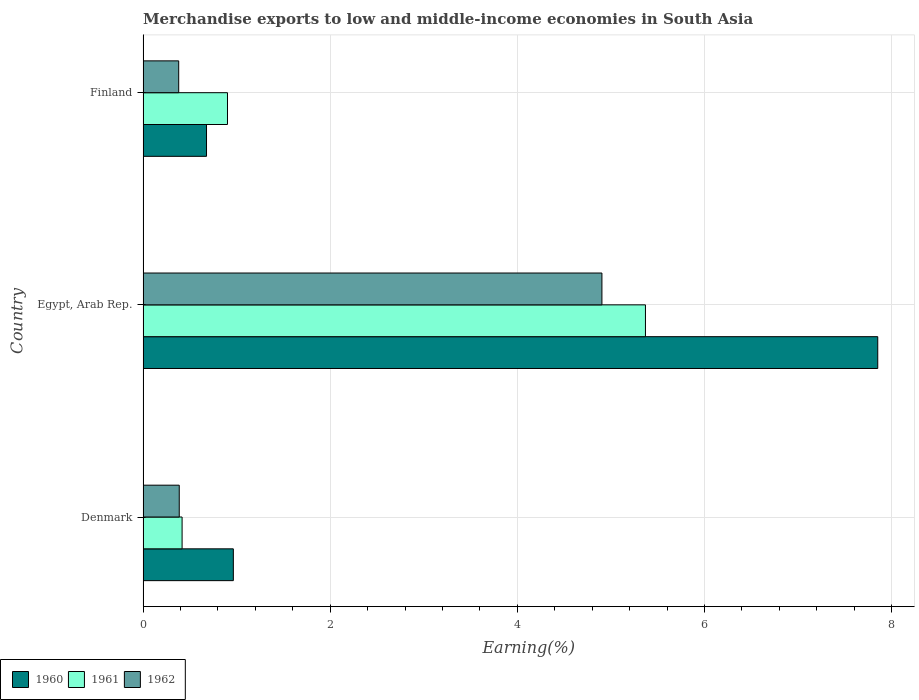How many different coloured bars are there?
Your answer should be very brief. 3. How many groups of bars are there?
Keep it short and to the point. 3. Are the number of bars per tick equal to the number of legend labels?
Offer a terse response. Yes. Are the number of bars on each tick of the Y-axis equal?
Offer a very short reply. Yes. How many bars are there on the 3rd tick from the bottom?
Keep it short and to the point. 3. What is the percentage of amount earned from merchandise exports in 1960 in Denmark?
Your answer should be compact. 0.96. Across all countries, what is the maximum percentage of amount earned from merchandise exports in 1961?
Make the answer very short. 5.37. Across all countries, what is the minimum percentage of amount earned from merchandise exports in 1961?
Keep it short and to the point. 0.42. In which country was the percentage of amount earned from merchandise exports in 1962 maximum?
Provide a short and direct response. Egypt, Arab Rep. In which country was the percentage of amount earned from merchandise exports in 1962 minimum?
Your answer should be compact. Finland. What is the total percentage of amount earned from merchandise exports in 1961 in the graph?
Your answer should be very brief. 6.69. What is the difference between the percentage of amount earned from merchandise exports in 1960 in Denmark and that in Egypt, Arab Rep.?
Give a very brief answer. -6.89. What is the difference between the percentage of amount earned from merchandise exports in 1962 in Denmark and the percentage of amount earned from merchandise exports in 1960 in Egypt, Arab Rep.?
Your response must be concise. -7.46. What is the average percentage of amount earned from merchandise exports in 1960 per country?
Provide a succinct answer. 3.16. What is the difference between the percentage of amount earned from merchandise exports in 1961 and percentage of amount earned from merchandise exports in 1962 in Egypt, Arab Rep.?
Ensure brevity in your answer.  0.47. In how many countries, is the percentage of amount earned from merchandise exports in 1962 greater than 7.2 %?
Provide a short and direct response. 0. What is the ratio of the percentage of amount earned from merchandise exports in 1961 in Denmark to that in Finland?
Ensure brevity in your answer.  0.46. Is the percentage of amount earned from merchandise exports in 1960 in Denmark less than that in Finland?
Provide a short and direct response. No. Is the difference between the percentage of amount earned from merchandise exports in 1961 in Denmark and Finland greater than the difference between the percentage of amount earned from merchandise exports in 1962 in Denmark and Finland?
Provide a short and direct response. No. What is the difference between the highest and the second highest percentage of amount earned from merchandise exports in 1960?
Your answer should be very brief. 6.89. What is the difference between the highest and the lowest percentage of amount earned from merchandise exports in 1961?
Keep it short and to the point. 4.95. In how many countries, is the percentage of amount earned from merchandise exports in 1962 greater than the average percentage of amount earned from merchandise exports in 1962 taken over all countries?
Your response must be concise. 1. What does the 1st bar from the bottom in Finland represents?
Give a very brief answer. 1960. Are all the bars in the graph horizontal?
Keep it short and to the point. Yes. Are the values on the major ticks of X-axis written in scientific E-notation?
Make the answer very short. No. Does the graph contain any zero values?
Offer a terse response. No. What is the title of the graph?
Offer a terse response. Merchandise exports to low and middle-income economies in South Asia. Does "2000" appear as one of the legend labels in the graph?
Ensure brevity in your answer.  No. What is the label or title of the X-axis?
Keep it short and to the point. Earning(%). What is the Earning(%) of 1960 in Denmark?
Your answer should be very brief. 0.96. What is the Earning(%) in 1961 in Denmark?
Offer a very short reply. 0.42. What is the Earning(%) of 1962 in Denmark?
Your answer should be compact. 0.39. What is the Earning(%) of 1960 in Egypt, Arab Rep.?
Make the answer very short. 7.85. What is the Earning(%) in 1961 in Egypt, Arab Rep.?
Make the answer very short. 5.37. What is the Earning(%) in 1962 in Egypt, Arab Rep.?
Ensure brevity in your answer.  4.9. What is the Earning(%) of 1960 in Finland?
Keep it short and to the point. 0.68. What is the Earning(%) in 1961 in Finland?
Ensure brevity in your answer.  0.9. What is the Earning(%) of 1962 in Finland?
Make the answer very short. 0.38. Across all countries, what is the maximum Earning(%) of 1960?
Your answer should be compact. 7.85. Across all countries, what is the maximum Earning(%) in 1961?
Offer a terse response. 5.37. Across all countries, what is the maximum Earning(%) in 1962?
Give a very brief answer. 4.9. Across all countries, what is the minimum Earning(%) in 1960?
Your response must be concise. 0.68. Across all countries, what is the minimum Earning(%) of 1961?
Ensure brevity in your answer.  0.42. Across all countries, what is the minimum Earning(%) of 1962?
Offer a terse response. 0.38. What is the total Earning(%) in 1960 in the graph?
Provide a short and direct response. 9.49. What is the total Earning(%) in 1961 in the graph?
Offer a very short reply. 6.69. What is the total Earning(%) of 1962 in the graph?
Your response must be concise. 5.67. What is the difference between the Earning(%) of 1960 in Denmark and that in Egypt, Arab Rep.?
Keep it short and to the point. -6.89. What is the difference between the Earning(%) of 1961 in Denmark and that in Egypt, Arab Rep.?
Provide a succinct answer. -4.95. What is the difference between the Earning(%) in 1962 in Denmark and that in Egypt, Arab Rep.?
Give a very brief answer. -4.52. What is the difference between the Earning(%) in 1960 in Denmark and that in Finland?
Ensure brevity in your answer.  0.29. What is the difference between the Earning(%) of 1961 in Denmark and that in Finland?
Ensure brevity in your answer.  -0.49. What is the difference between the Earning(%) in 1962 in Denmark and that in Finland?
Ensure brevity in your answer.  0.01. What is the difference between the Earning(%) in 1960 in Egypt, Arab Rep. and that in Finland?
Make the answer very short. 7.17. What is the difference between the Earning(%) of 1961 in Egypt, Arab Rep. and that in Finland?
Keep it short and to the point. 4.47. What is the difference between the Earning(%) in 1962 in Egypt, Arab Rep. and that in Finland?
Your answer should be very brief. 4.52. What is the difference between the Earning(%) of 1960 in Denmark and the Earning(%) of 1961 in Egypt, Arab Rep.?
Provide a short and direct response. -4.4. What is the difference between the Earning(%) of 1960 in Denmark and the Earning(%) of 1962 in Egypt, Arab Rep.?
Give a very brief answer. -3.94. What is the difference between the Earning(%) in 1961 in Denmark and the Earning(%) in 1962 in Egypt, Arab Rep.?
Provide a succinct answer. -4.49. What is the difference between the Earning(%) in 1960 in Denmark and the Earning(%) in 1961 in Finland?
Your response must be concise. 0.06. What is the difference between the Earning(%) in 1960 in Denmark and the Earning(%) in 1962 in Finland?
Provide a succinct answer. 0.58. What is the difference between the Earning(%) of 1961 in Denmark and the Earning(%) of 1962 in Finland?
Offer a very short reply. 0.04. What is the difference between the Earning(%) in 1960 in Egypt, Arab Rep. and the Earning(%) in 1961 in Finland?
Your response must be concise. 6.95. What is the difference between the Earning(%) of 1960 in Egypt, Arab Rep. and the Earning(%) of 1962 in Finland?
Give a very brief answer. 7.47. What is the difference between the Earning(%) in 1961 in Egypt, Arab Rep. and the Earning(%) in 1962 in Finland?
Make the answer very short. 4.99. What is the average Earning(%) of 1960 per country?
Your response must be concise. 3.16. What is the average Earning(%) in 1961 per country?
Your response must be concise. 2.23. What is the average Earning(%) in 1962 per country?
Offer a very short reply. 1.89. What is the difference between the Earning(%) in 1960 and Earning(%) in 1961 in Denmark?
Provide a short and direct response. 0.55. What is the difference between the Earning(%) of 1960 and Earning(%) of 1962 in Denmark?
Your answer should be compact. 0.58. What is the difference between the Earning(%) in 1961 and Earning(%) in 1962 in Denmark?
Offer a terse response. 0.03. What is the difference between the Earning(%) in 1960 and Earning(%) in 1961 in Egypt, Arab Rep.?
Keep it short and to the point. 2.48. What is the difference between the Earning(%) in 1960 and Earning(%) in 1962 in Egypt, Arab Rep.?
Provide a succinct answer. 2.95. What is the difference between the Earning(%) in 1961 and Earning(%) in 1962 in Egypt, Arab Rep.?
Provide a short and direct response. 0.47. What is the difference between the Earning(%) of 1960 and Earning(%) of 1961 in Finland?
Provide a short and direct response. -0.22. What is the difference between the Earning(%) of 1960 and Earning(%) of 1962 in Finland?
Offer a very short reply. 0.3. What is the difference between the Earning(%) in 1961 and Earning(%) in 1962 in Finland?
Provide a short and direct response. 0.52. What is the ratio of the Earning(%) in 1960 in Denmark to that in Egypt, Arab Rep.?
Provide a short and direct response. 0.12. What is the ratio of the Earning(%) in 1961 in Denmark to that in Egypt, Arab Rep.?
Make the answer very short. 0.08. What is the ratio of the Earning(%) of 1962 in Denmark to that in Egypt, Arab Rep.?
Your response must be concise. 0.08. What is the ratio of the Earning(%) in 1960 in Denmark to that in Finland?
Your response must be concise. 1.42. What is the ratio of the Earning(%) of 1961 in Denmark to that in Finland?
Provide a short and direct response. 0.46. What is the ratio of the Earning(%) of 1962 in Denmark to that in Finland?
Ensure brevity in your answer.  1.02. What is the ratio of the Earning(%) in 1960 in Egypt, Arab Rep. to that in Finland?
Give a very brief answer. 11.58. What is the ratio of the Earning(%) of 1961 in Egypt, Arab Rep. to that in Finland?
Your answer should be very brief. 5.95. What is the ratio of the Earning(%) in 1962 in Egypt, Arab Rep. to that in Finland?
Give a very brief answer. 12.88. What is the difference between the highest and the second highest Earning(%) of 1960?
Ensure brevity in your answer.  6.89. What is the difference between the highest and the second highest Earning(%) of 1961?
Give a very brief answer. 4.47. What is the difference between the highest and the second highest Earning(%) of 1962?
Your answer should be very brief. 4.52. What is the difference between the highest and the lowest Earning(%) in 1960?
Keep it short and to the point. 7.17. What is the difference between the highest and the lowest Earning(%) in 1961?
Your response must be concise. 4.95. What is the difference between the highest and the lowest Earning(%) in 1962?
Offer a very short reply. 4.52. 